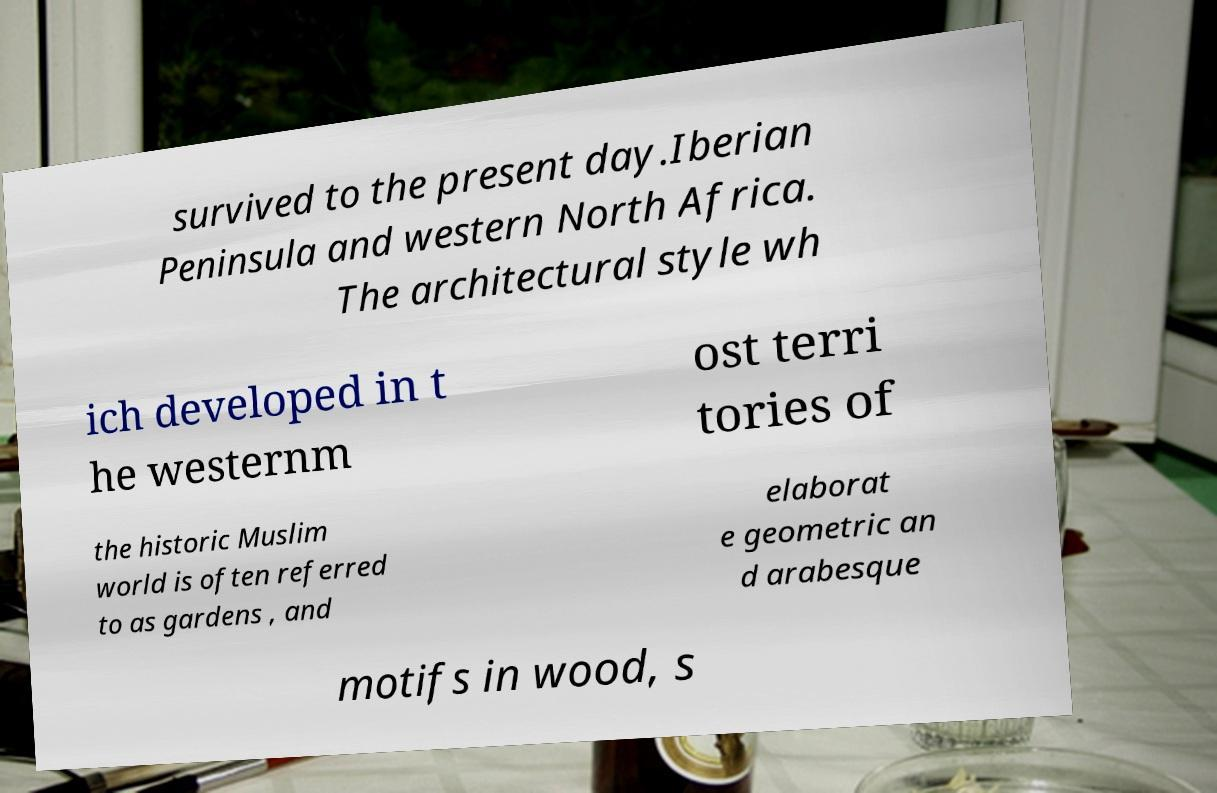For documentation purposes, I need the text within this image transcribed. Could you provide that? survived to the present day.Iberian Peninsula and western North Africa. The architectural style wh ich developed in t he westernm ost terri tories of the historic Muslim world is often referred to as gardens , and elaborat e geometric an d arabesque motifs in wood, s 